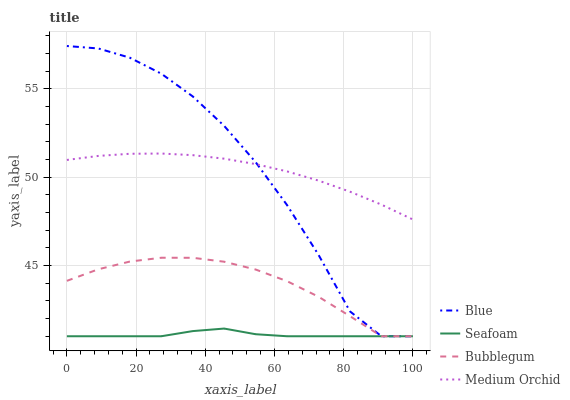Does Seafoam have the minimum area under the curve?
Answer yes or no. Yes. Does Blue have the maximum area under the curve?
Answer yes or no. Yes. Does Medium Orchid have the minimum area under the curve?
Answer yes or no. No. Does Medium Orchid have the maximum area under the curve?
Answer yes or no. No. Is Medium Orchid the smoothest?
Answer yes or no. Yes. Is Blue the roughest?
Answer yes or no. Yes. Is Seafoam the smoothest?
Answer yes or no. No. Is Seafoam the roughest?
Answer yes or no. No. Does Medium Orchid have the lowest value?
Answer yes or no. No. Does Medium Orchid have the highest value?
Answer yes or no. No. Is Seafoam less than Medium Orchid?
Answer yes or no. Yes. Is Medium Orchid greater than Seafoam?
Answer yes or no. Yes. Does Seafoam intersect Medium Orchid?
Answer yes or no. No. 